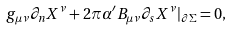Convert formula to latex. <formula><loc_0><loc_0><loc_500><loc_500>g _ { \mu \nu } \partial _ { n } X ^ { \nu } + 2 \pi \alpha ^ { \prime } B _ { \mu \nu } \partial _ { s } X ^ { \nu } | _ { \partial \Sigma } = 0 ,</formula> 